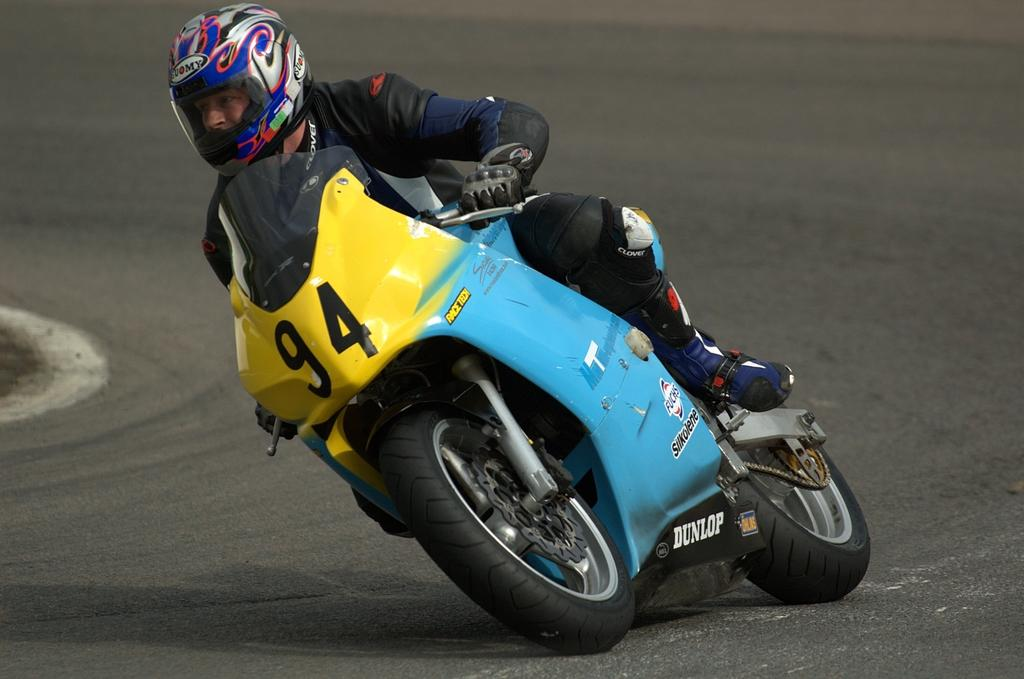Who or what is the main subject in the image? There is a person in the image. What is the person wearing? The person is wearing a helmet. What activity is the person engaged in? The person is riding a bike. Where is the bike located? The bike is on a road. What type of farm can be seen in the background of the image? There is no farm present in the image; it features a person riding a bike on a road. 